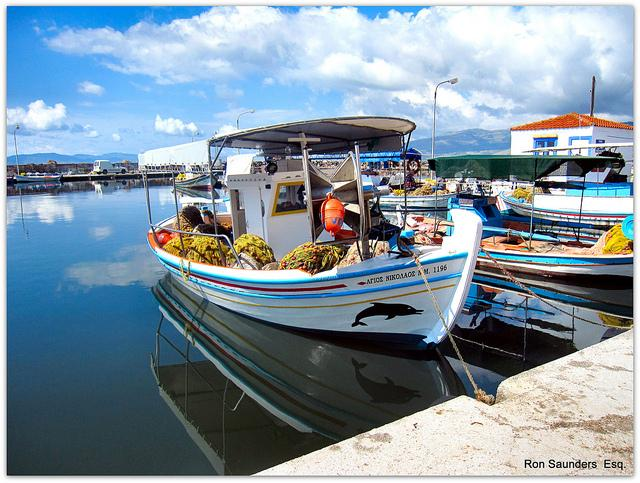What yellow items sits on the boat?

Choices:
A) stockings
B) bananas
C) net
D) mustard net 